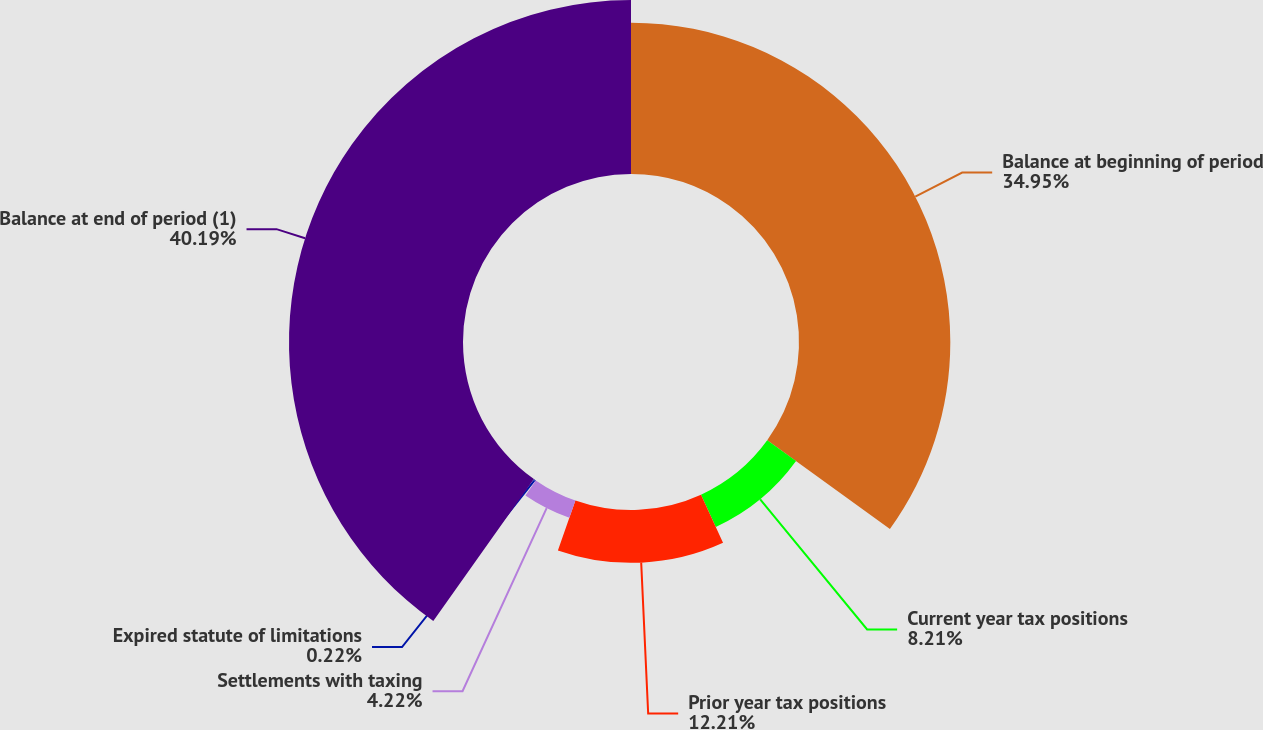Convert chart. <chart><loc_0><loc_0><loc_500><loc_500><pie_chart><fcel>Balance at beginning of period<fcel>Current year tax positions<fcel>Prior year tax positions<fcel>Settlements with taxing<fcel>Expired statute of limitations<fcel>Balance at end of period (1)<nl><fcel>34.95%<fcel>8.21%<fcel>12.21%<fcel>4.22%<fcel>0.22%<fcel>40.19%<nl></chart> 